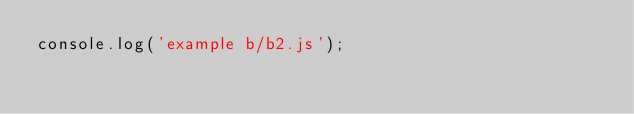<code> <loc_0><loc_0><loc_500><loc_500><_JavaScript_>console.log('example b/b2.js');</code> 